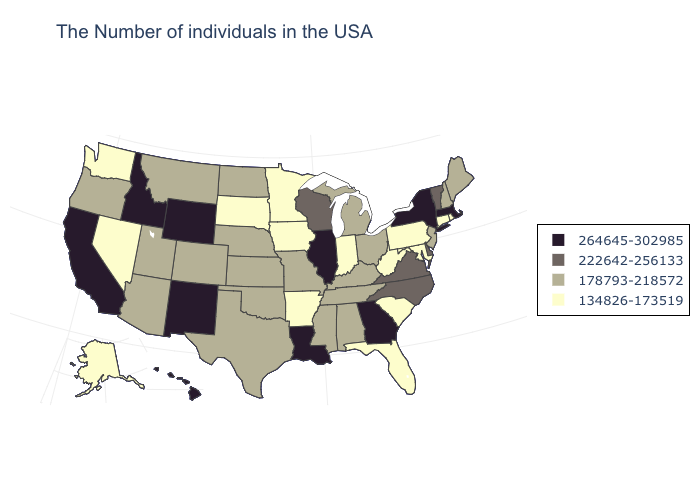Does Maryland have the lowest value in the South?
Give a very brief answer. Yes. Does the first symbol in the legend represent the smallest category?
Concise answer only. No. What is the lowest value in the South?
Write a very short answer. 134826-173519. Does New York have the highest value in the Northeast?
Keep it brief. Yes. Among the states that border Alabama , which have the lowest value?
Answer briefly. Florida. Name the states that have a value in the range 178793-218572?
Keep it brief. Maine, New Hampshire, New Jersey, Ohio, Michigan, Kentucky, Alabama, Tennessee, Mississippi, Missouri, Kansas, Nebraska, Oklahoma, Texas, North Dakota, Colorado, Utah, Montana, Arizona, Oregon. Does Rhode Island have the same value as Tennessee?
Concise answer only. No. Name the states that have a value in the range 264645-302985?
Be succinct. Massachusetts, New York, Georgia, Illinois, Louisiana, Wyoming, New Mexico, Idaho, California, Hawaii. Name the states that have a value in the range 134826-173519?
Be succinct. Rhode Island, Connecticut, Maryland, Pennsylvania, South Carolina, West Virginia, Florida, Indiana, Arkansas, Minnesota, Iowa, South Dakota, Nevada, Washington, Alaska. What is the highest value in states that border South Carolina?
Write a very short answer. 264645-302985. What is the value of New Mexico?
Answer briefly. 264645-302985. Name the states that have a value in the range 264645-302985?
Give a very brief answer. Massachusetts, New York, Georgia, Illinois, Louisiana, Wyoming, New Mexico, Idaho, California, Hawaii. Among the states that border New Hampshire , which have the lowest value?
Short answer required. Maine. Name the states that have a value in the range 264645-302985?
Write a very short answer. Massachusetts, New York, Georgia, Illinois, Louisiana, Wyoming, New Mexico, Idaho, California, Hawaii. What is the value of Florida?
Quick response, please. 134826-173519. 